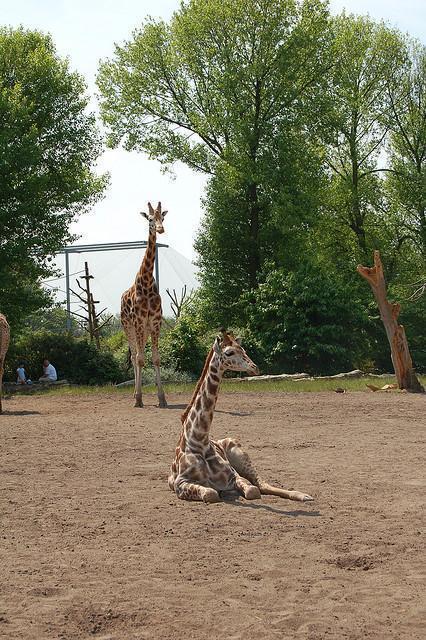What is the giraffe in the foreground doing?
Select the accurate response from the four choices given to answer the question.
Options: Jumping, sitting, running, eating grass. Sitting. 